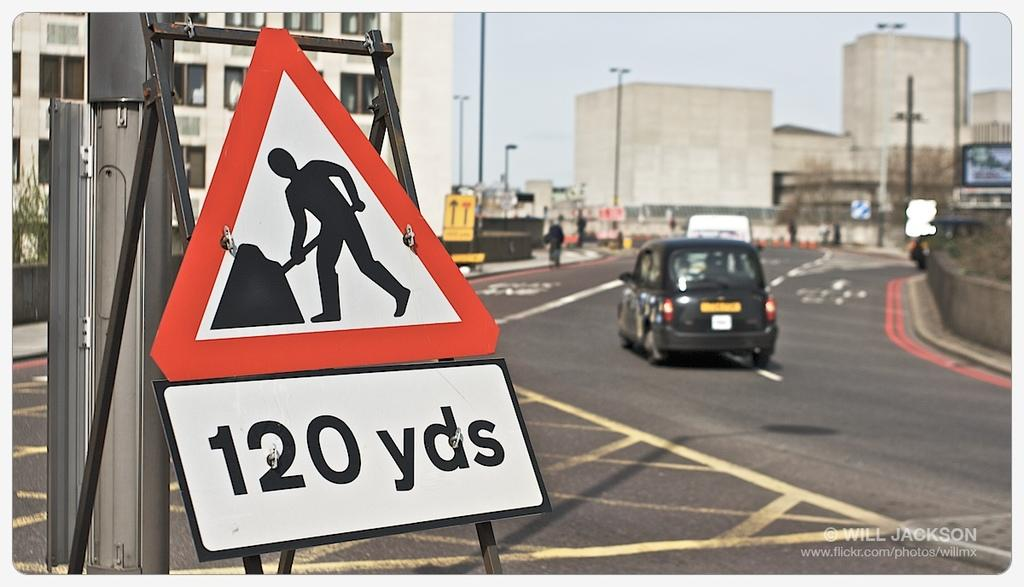Provide a one-sentence caption for the provided image. A warning workers road sign at 120 yards ahead on street. 